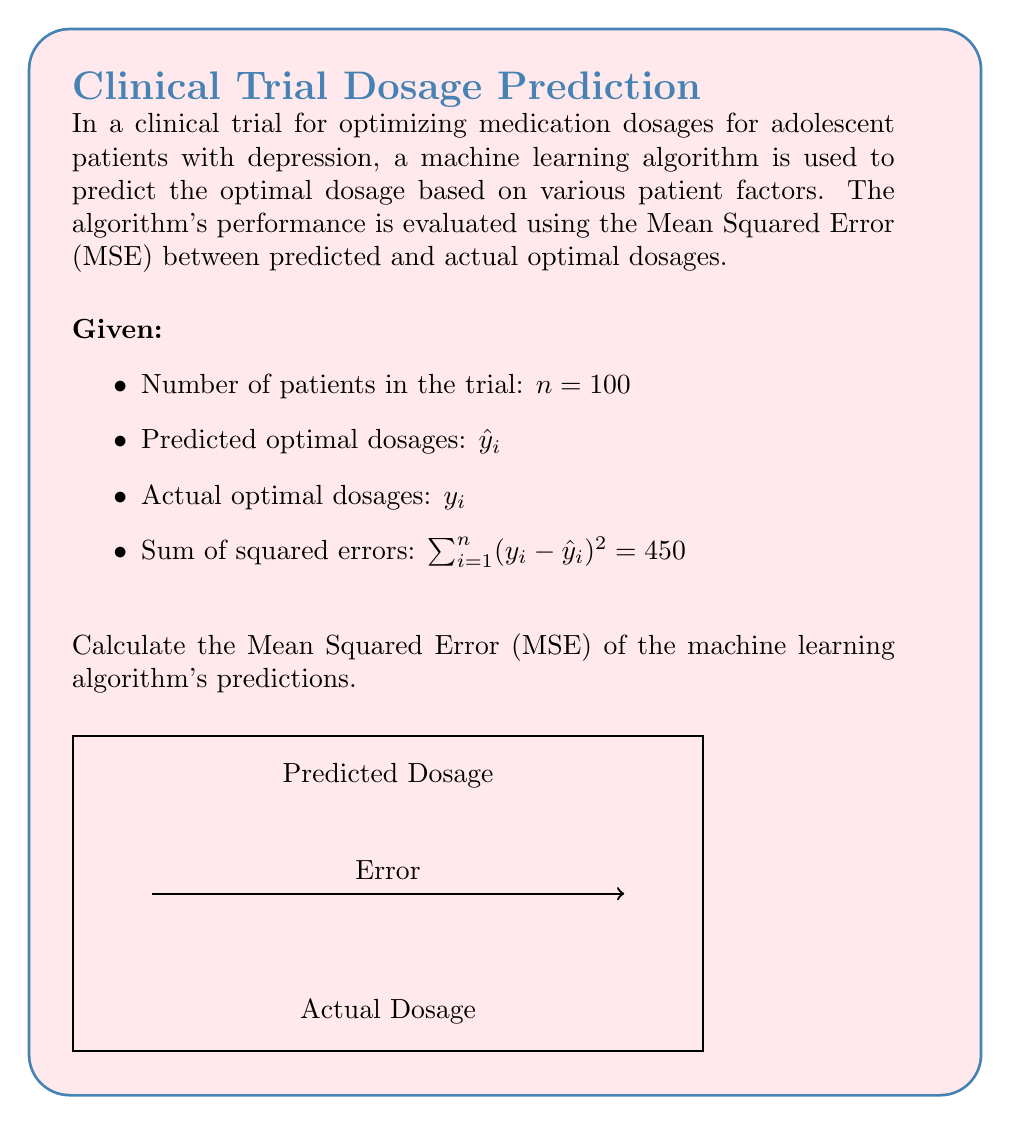Help me with this question. To calculate the Mean Squared Error (MSE), we need to follow these steps:

1) Recall the formula for MSE:
   $$MSE = \frac{1}{n} \sum_{i=1}^{n} (y_i - \hat{y}_i)^2$$

   Where:
   - $n$ is the number of samples (patients in this case)
   - $y_i$ is the actual optimal dosage for patient $i$
   - $\hat{y}_i$ is the predicted optimal dosage for patient $i$

2) We are given that:
   - $n = 100$
   - $\sum_{i=1}^{n} (y_i - \hat{y}_i)^2 = 450$

3) Substituting these values into the MSE formula:

   $$MSE = \frac{1}{100} \cdot 450$$

4) Simplify:
   $$MSE = 4.5$$

Therefore, the Mean Squared Error of the machine learning algorithm's predictions is 4.5.
Answer: 4.5 